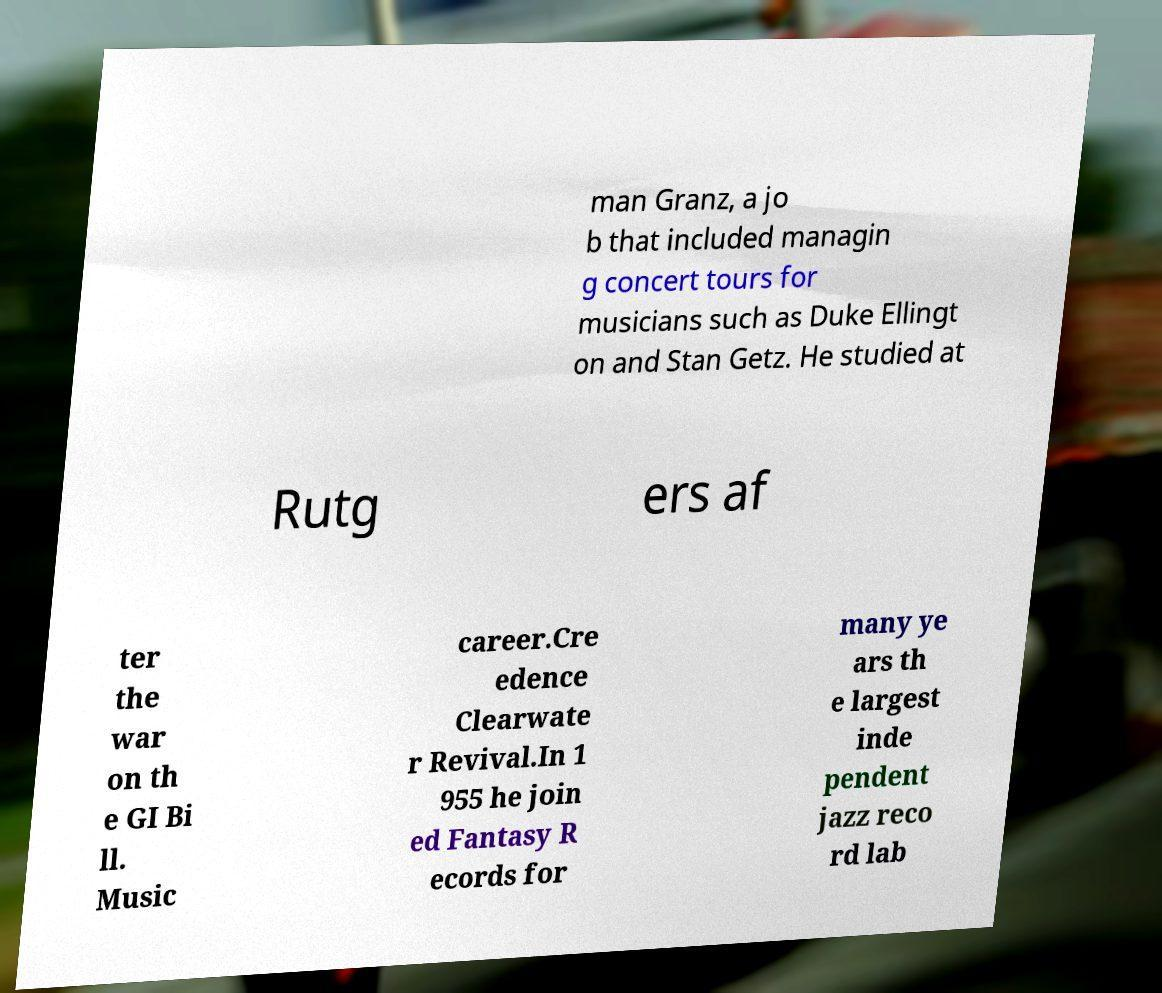Could you assist in decoding the text presented in this image and type it out clearly? man Granz, a jo b that included managin g concert tours for musicians such as Duke Ellingt on and Stan Getz. He studied at Rutg ers af ter the war on th e GI Bi ll. Music career.Cre edence Clearwate r Revival.In 1 955 he join ed Fantasy R ecords for many ye ars th e largest inde pendent jazz reco rd lab 